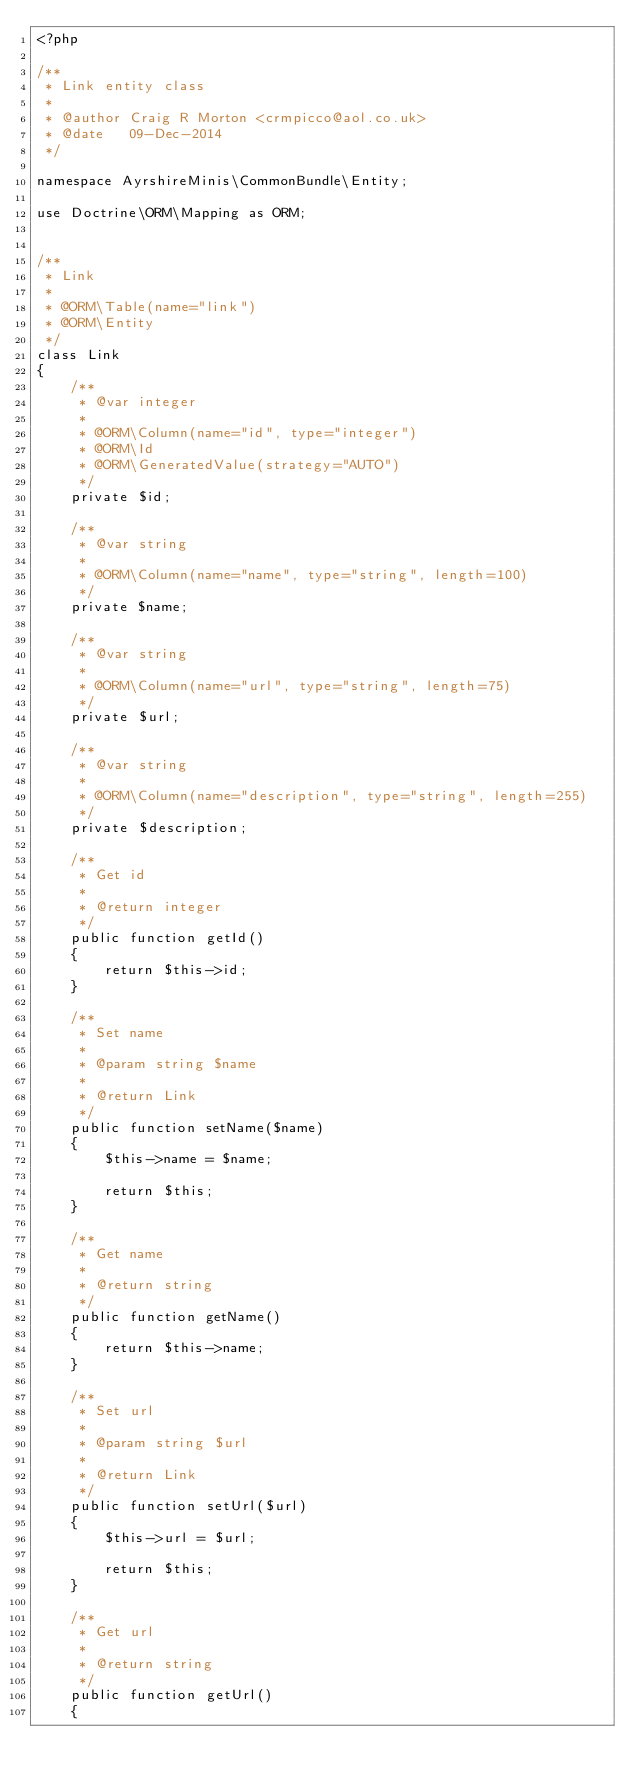Convert code to text. <code><loc_0><loc_0><loc_500><loc_500><_PHP_><?php

/**
 * Link entity class
 *
 * @author Craig R Morton <crmpicco@aol.co.uk>
 * @date   09-Dec-2014
 */

namespace AyrshireMinis\CommonBundle\Entity;

use Doctrine\ORM\Mapping as ORM;


/**
 * Link
 *
 * @ORM\Table(name="link")
 * @ORM\Entity
 */
class Link
{
    /**
     * @var integer
     *
     * @ORM\Column(name="id", type="integer")
     * @ORM\Id
     * @ORM\GeneratedValue(strategy="AUTO")
     */
    private $id;

    /**
     * @var string
     *
     * @ORM\Column(name="name", type="string", length=100)
     */
    private $name;

    /**
     * @var string
     *
     * @ORM\Column(name="url", type="string", length=75)
     */
    private $url;

    /**
     * @var string
     *
     * @ORM\Column(name="description", type="string", length=255)
     */
    private $description;

    /**
     * Get id
     *
     * @return integer
     */
    public function getId()
    {
        return $this->id;
    }

    /**
     * Set name
     *
     * @param string $name
     *
     * @return Link
     */
    public function setName($name)
    {
        $this->name = $name;

        return $this;
    }

    /**
     * Get name
     *
     * @return string
     */
    public function getName()
    {
        return $this->name;
    }

    /**
     * Set url
     *
     * @param string $url
     *
     * @return Link
     */
    public function setUrl($url)
    {
        $this->url = $url;

        return $this;
    }

    /**
     * Get url
     *
     * @return string
     */
    public function getUrl()
    {</code> 